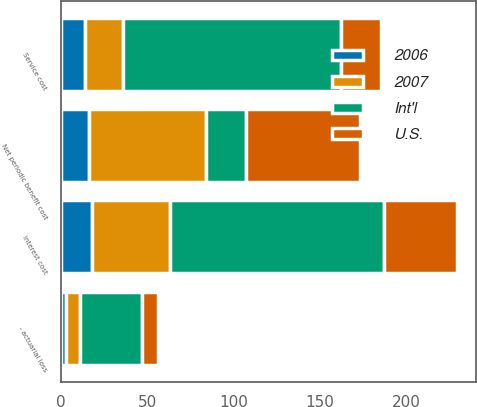Convert chart to OTSL. <chart><loc_0><loc_0><loc_500><loc_500><stacked_bar_chart><ecel><fcel>Service cost<fcel>Interest cost<fcel>- actuarial loss<fcel>Net periodic benefit cost<nl><fcel>Int'l<fcel>126<fcel>124<fcel>36<fcel>23<nl><fcel>2006<fcel>14<fcel>18<fcel>3<fcel>16<nl><fcel>2007<fcel>22<fcel>45<fcel>8<fcel>68<nl><fcel>U.S.<fcel>23<fcel>42<fcel>9<fcel>66<nl></chart> 